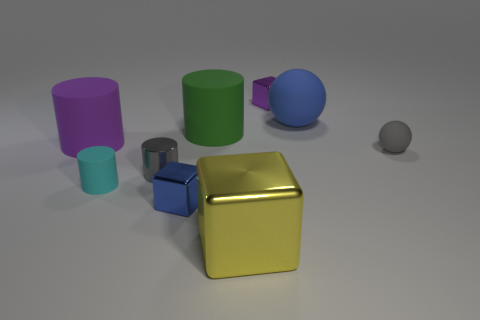What number of other things are the same color as the big metal cube?
Keep it short and to the point. 0. Do the cube that is behind the gray shiny cylinder and the blue object to the left of the big yellow cube have the same size?
Give a very brief answer. Yes. Is the purple cylinder made of the same material as the gray object that is on the right side of the big yellow metallic block?
Your answer should be compact. Yes. Are there more rubber things behind the tiny cyan cylinder than big yellow blocks that are on the right side of the gray rubber object?
Offer a very short reply. Yes. There is a shiny thing behind the sphere that is behind the tiny gray sphere; what is its color?
Offer a very short reply. Purple. What number of blocks are either blue matte things or purple matte objects?
Offer a terse response. 0. How many metallic blocks are both behind the large yellow metal thing and in front of the tiny cyan cylinder?
Offer a terse response. 1. What is the color of the small cube that is right of the green thing?
Your answer should be compact. Purple. There is a gray thing that is made of the same material as the big purple cylinder; what size is it?
Give a very brief answer. Small. What number of cubes are behind the big rubber thing on the left side of the metallic cylinder?
Offer a terse response. 1. 